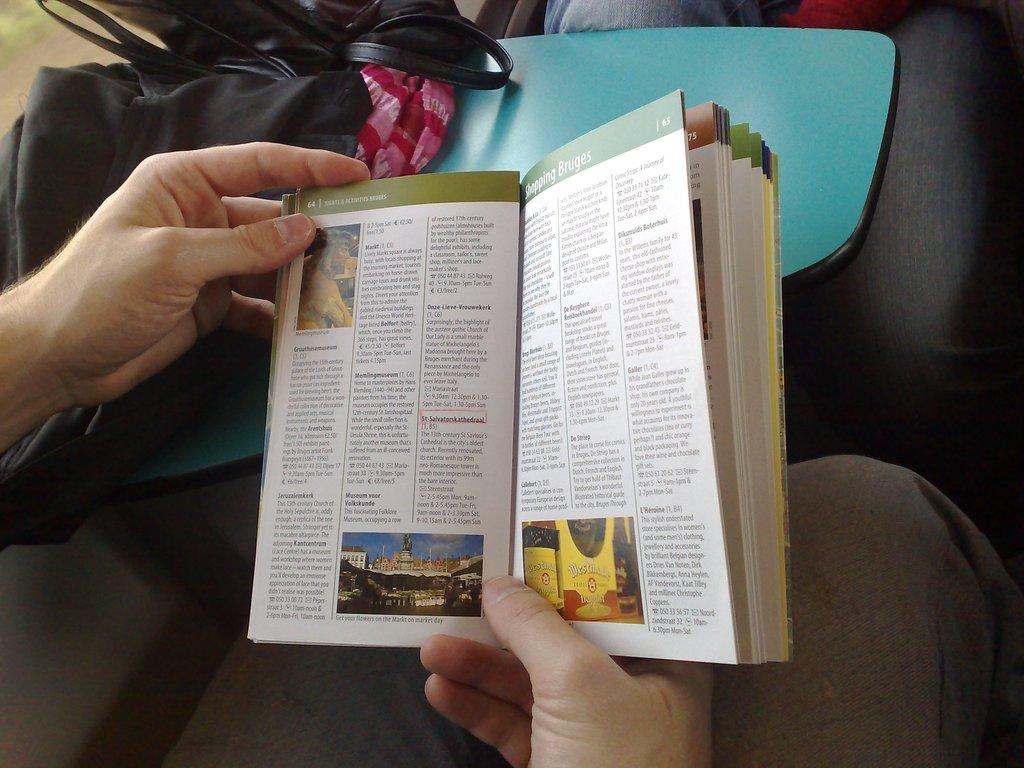<image>
Render a clear and concise summary of the photo. A travel guide is open to page 65 for shopping Bruges. 